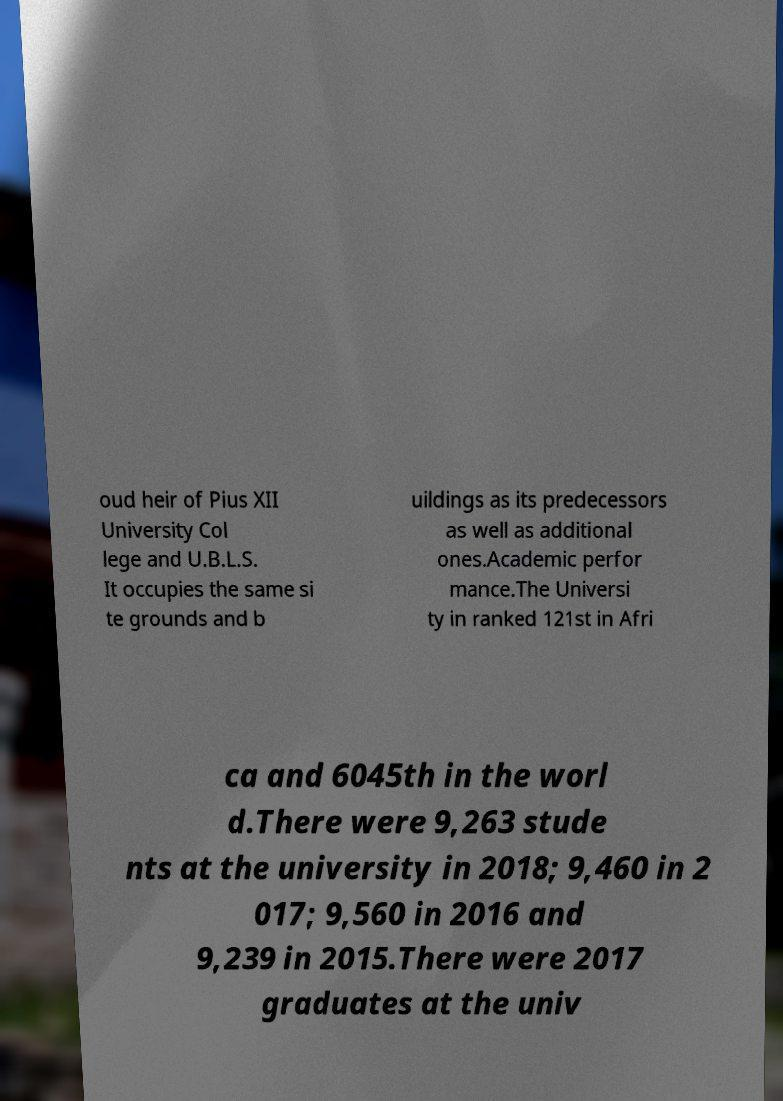Please read and relay the text visible in this image. What does it say? oud heir of Pius XII University Col lege and U.B.L.S. It occupies the same si te grounds and b uildings as its predecessors as well as additional ones.Academic perfor mance.The Universi ty in ranked 121st in Afri ca and 6045th in the worl d.There were 9,263 stude nts at the university in 2018; 9,460 in 2 017; 9,560 in 2016 and 9,239 in 2015.There were 2017 graduates at the univ 